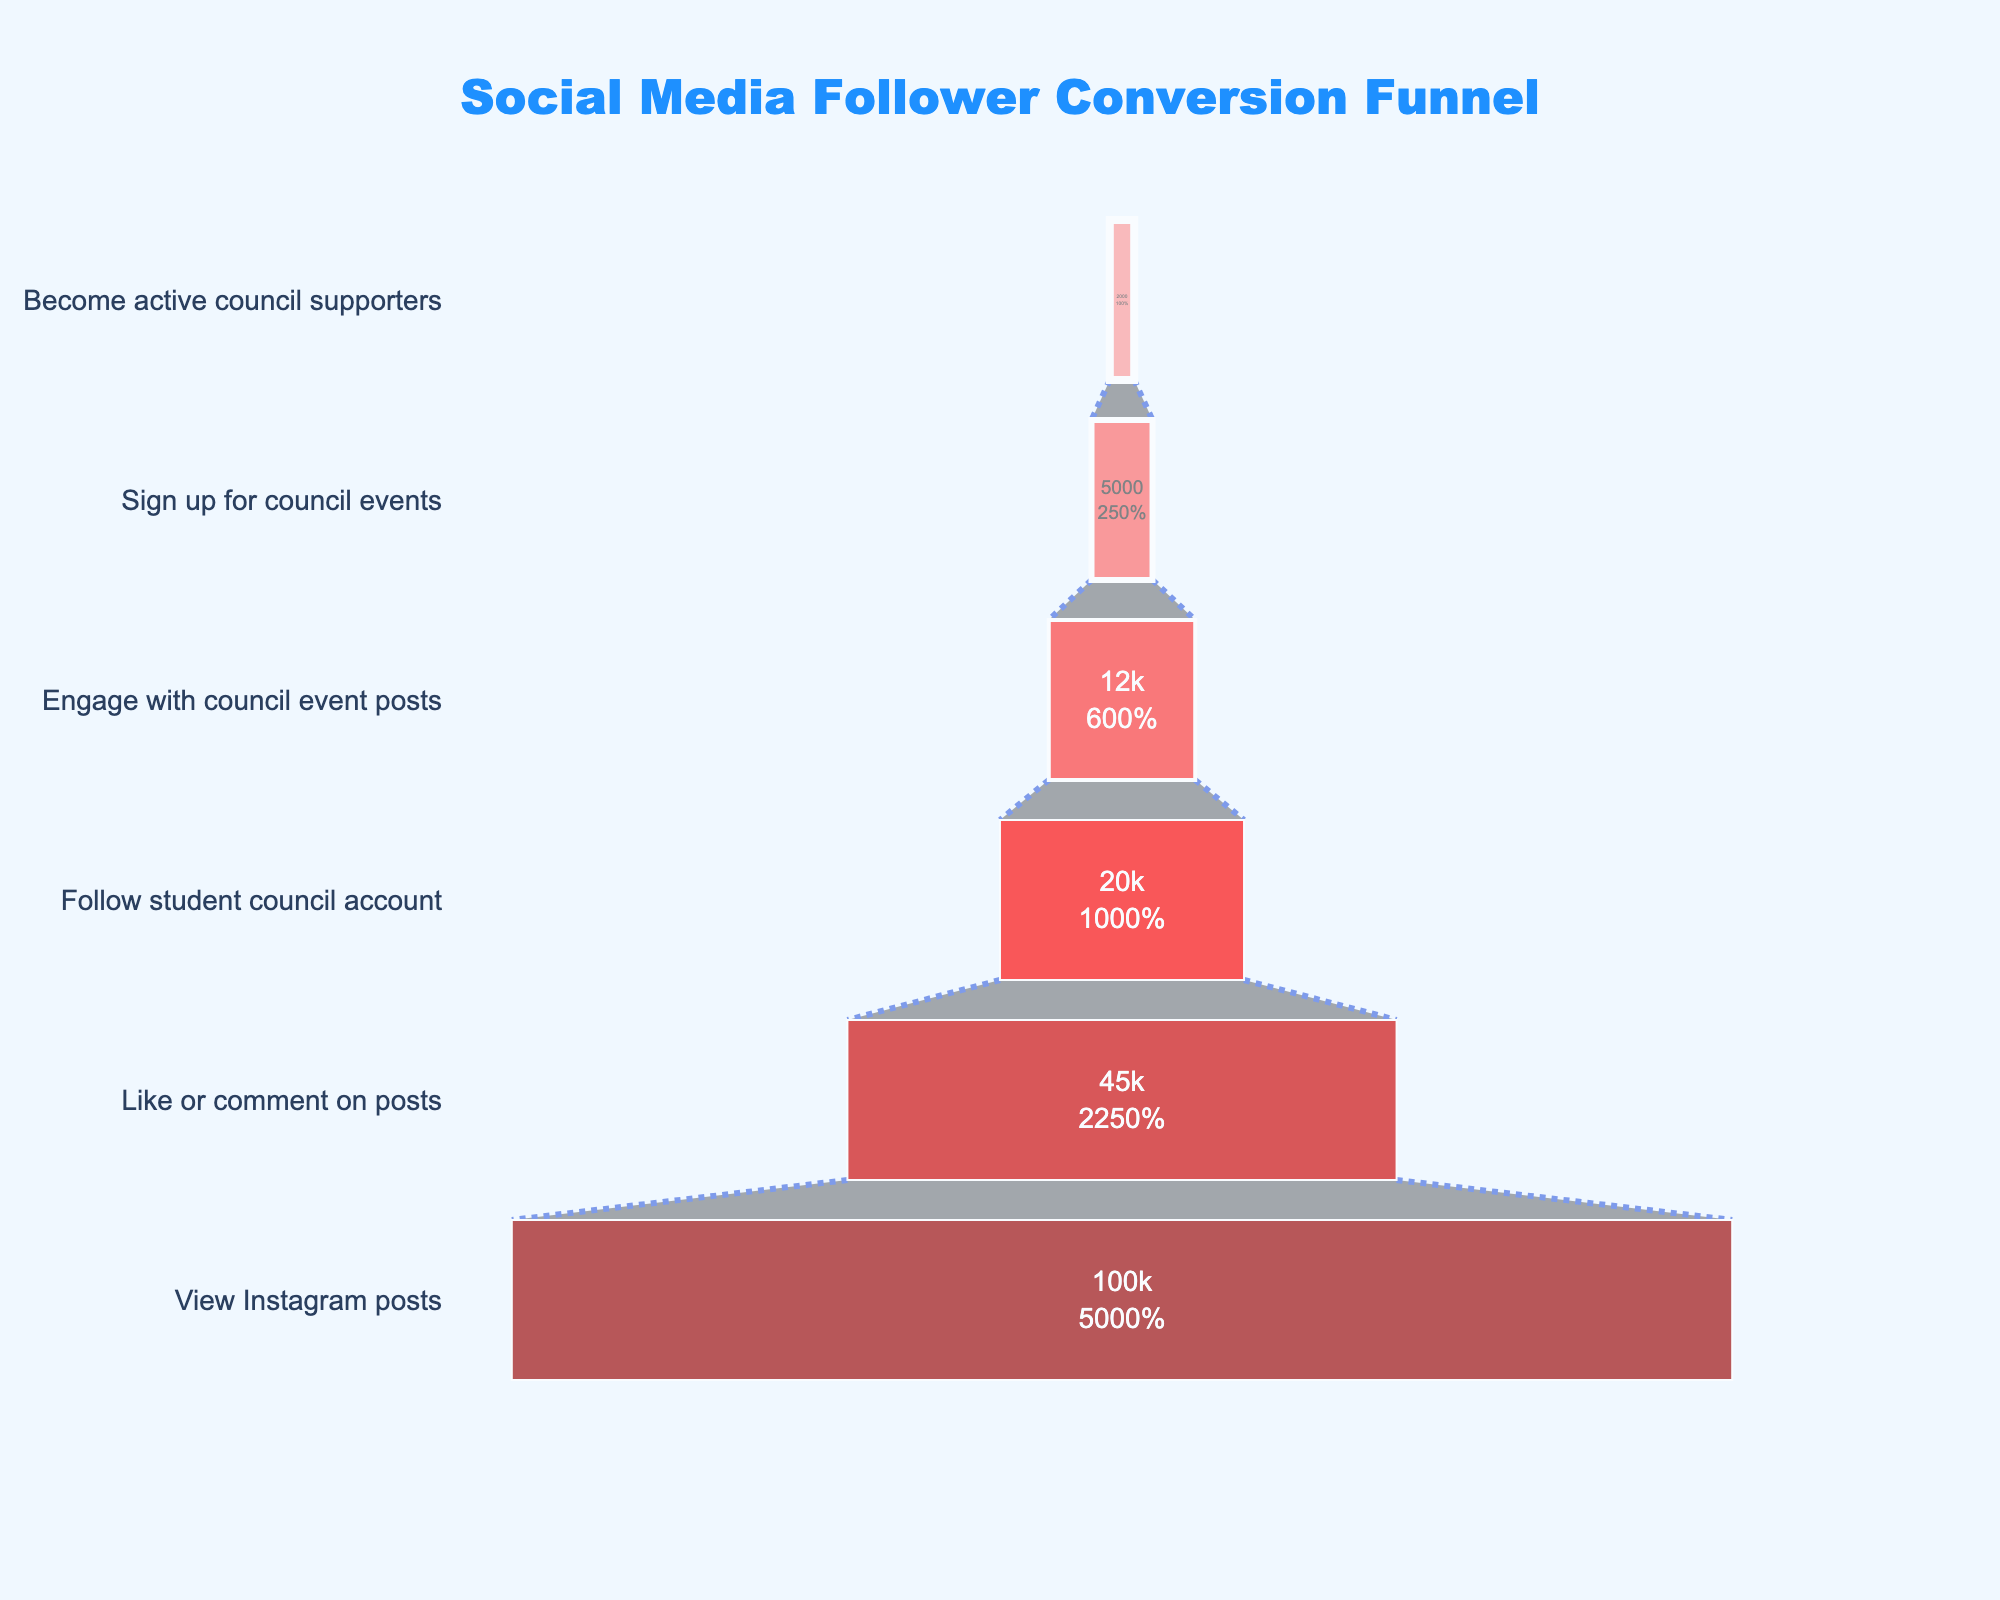what is the title of the chart? The title is located at the top of the chart. It reads "Social Media Follower Conversion Funnel".
Answer: Social Media Follower Conversion Funnel How many stages are in the funnel chart? By counting the labels on the y-axis, there are six stages: View Instagram posts, Like or comment on posts, Follow student council account, Engage with council event posts, Sign up for council events, and Become active council supporters.
Answer: Six What color is the stage with the highest number of people? The stage with the highest number of people is "View Instagram posts" with 100,000 people. The color of this stage is light pink.
Answer: light pink What's the percentage drop from "Follow student council account" to "Engage with council event posts"? The number of people drops from 20,000 to 12,000. The percentage drop is calculated as (1 - 12,000/20,000) * 100%.
Answer: 40% Which stage has the smallest number of people? The stage with the smallest number of people is "Become active council supporters," which has 2,000 people.
Answer: Become active council supporters How much do the numbers decrease from "Sign up for council events" to "Become active council supporters"? Subtract the number of people in the "Become active council supporters" stage from the "Sign up for council events" stage: 5,000 - 2,000.
Answer: 3,000 Which two stages have the greatest percentage drop between them? Calculate the percentage drop for each stage transition:
1. View Instagram posts to Like or comment on posts: (55%)
2. Like or comment on posts to Follow student council account: (55.6%)
3. Follow student council account to Engage with council event posts: (40%)
4. Engage with council event posts to Sign up for council events: (58.3%)
5. Sign up for council events to Become active council supporters: (60%)
The greatest percentage drop is between "Sign up for council events" and "Become active council supporters".
Answer: Sign up for council events to Become active council supporters Which stage has the most people engaging compared to the previous one? By calculating the engagement rates:
1. From View Instagram posts to Like or comment on posts: 45%
2. From Like or comment on posts to Follow student council account: 44.4%
3. From Follow student council account to Engage with council event posts: 60%
4. From Engage with council event posts to Sign up for council events: 41.7%
5. From Sign up for council events to Become active council supporters: 40%
The highest engagement rate is between "Follow student council account" and "Engage with council event posts".
Answer: Follow student council account to Engage with council event posts What stage has almost half of the total number of people converting from the previous stage? Compare the conversion ratios:
1. View Instagram posts to Like or comment on posts: 45%
2. Like or comment on posts to Follow student council account: 44.4%
3. Follow student council account to Engage with council event posts: 60%
4. Engage with council event posts to Sign up for council events: 41.7%
5. Sign up for council events to Become active council supporters: 40%
"View Instagram posts" to "Like or comment on posts" is almost half, at 45%.
Answer: View Instagram posts to Like or comment on posts 